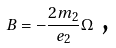<formula> <loc_0><loc_0><loc_500><loc_500>B = - \frac { 2 m _ { 2 } } { e _ { 2 } } \Omega \text { ,}</formula> 